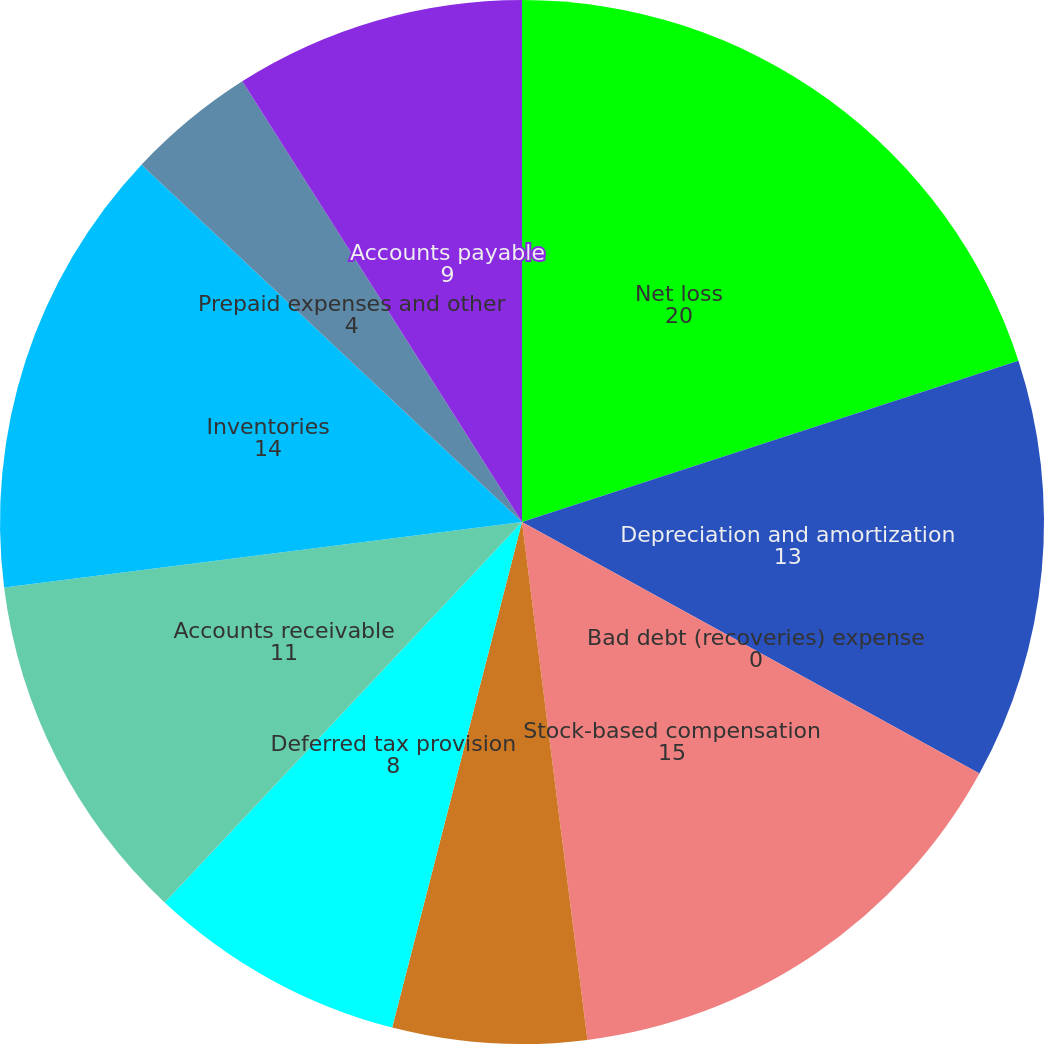<chart> <loc_0><loc_0><loc_500><loc_500><pie_chart><fcel>Net loss<fcel>Depreciation and amortization<fcel>Bad debt (recoveries) expense<fcel>Stock-based compensation<fcel>Write-down of inventory<fcel>Deferred tax provision<fcel>Accounts receivable<fcel>Inventories<fcel>Prepaid expenses and other<fcel>Accounts payable<nl><fcel>20.0%<fcel>13.0%<fcel>0.0%<fcel>15.0%<fcel>6.0%<fcel>8.0%<fcel>11.0%<fcel>14.0%<fcel>4.0%<fcel>9.0%<nl></chart> 